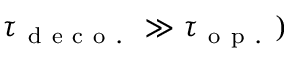<formula> <loc_0><loc_0><loc_500><loc_500>\tau _ { d e c o . } \gg \tau _ { o p . } )</formula> 